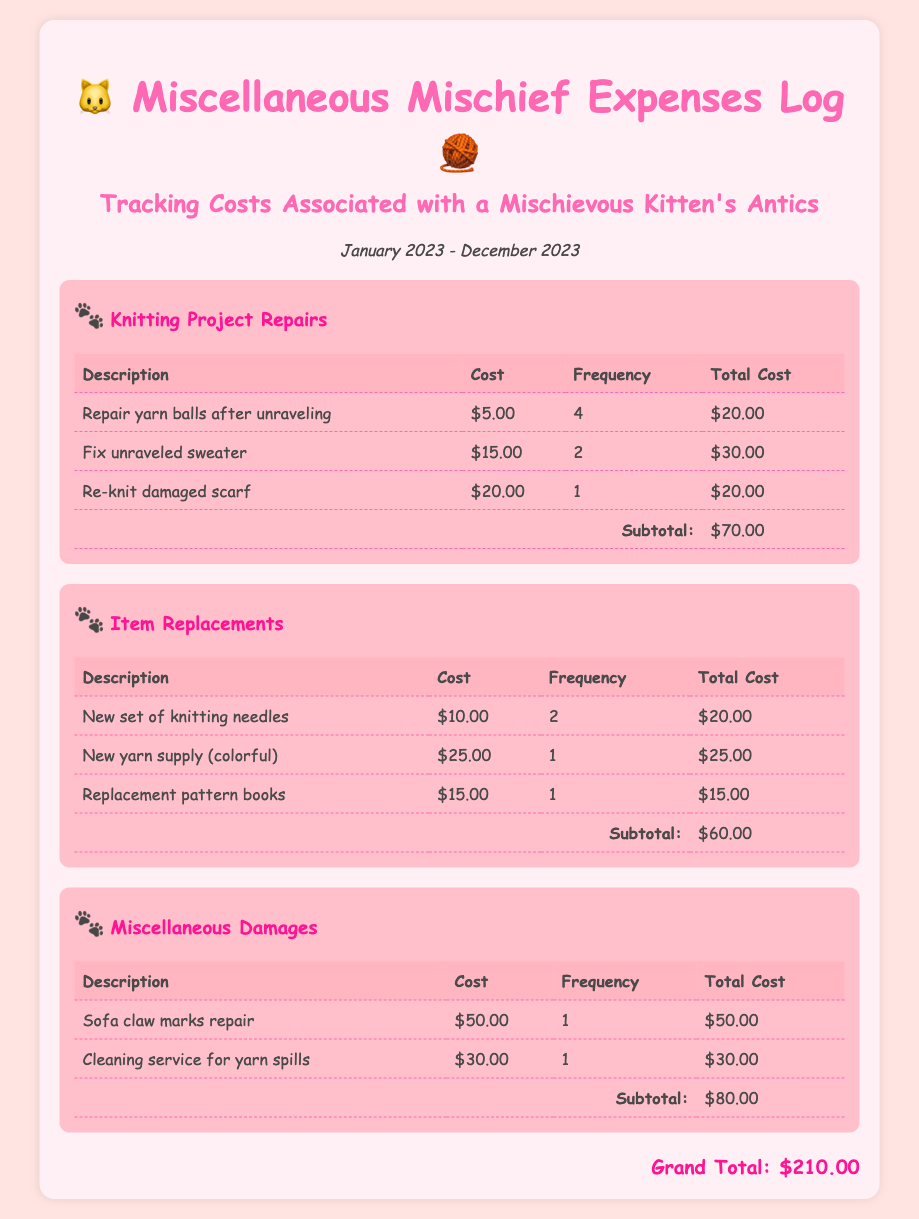What is the total cost for knitting project repairs? The total cost is shown in the subtotal for knitting project repairs, which is $70.00.
Answer: $70.00 How many new sets of knitting needles were purchased? The frequency listed for new sets of knitting needles is 2.
Answer: 2 What is the cost of fixing the unraveled sweater? The cost for fixing the unraveled sweater is clearly indicated as $15.00.
Answer: $15.00 What is the grand total for all expenses logged? The grand total sums up all categories of expenses in the document, amounting to $210.00.
Answer: $210.00 How much was spent on cleaning services for yarn spills? This expense is mentioned under miscellaneous damages as $30.00.
Answer: $30.00 What item was replaced for $25.00? The document states that new yarn supply (colorful) costs $25.00.
Answer: New yarn supply (colorful) What is the frequency of re-knitting the damaged scarf? The frequency for re-knitting the damaged scarf is 1.
Answer: 1 How many repairs were done for yarn balls after unraveling? The frequency for repairing yarn balls is given as 4.
Answer: 4 What category has the highest subtotal? The category with the highest subtotal is miscellaneous damages with a subtotal of $80.00.
Answer: Miscellaneous Damages 